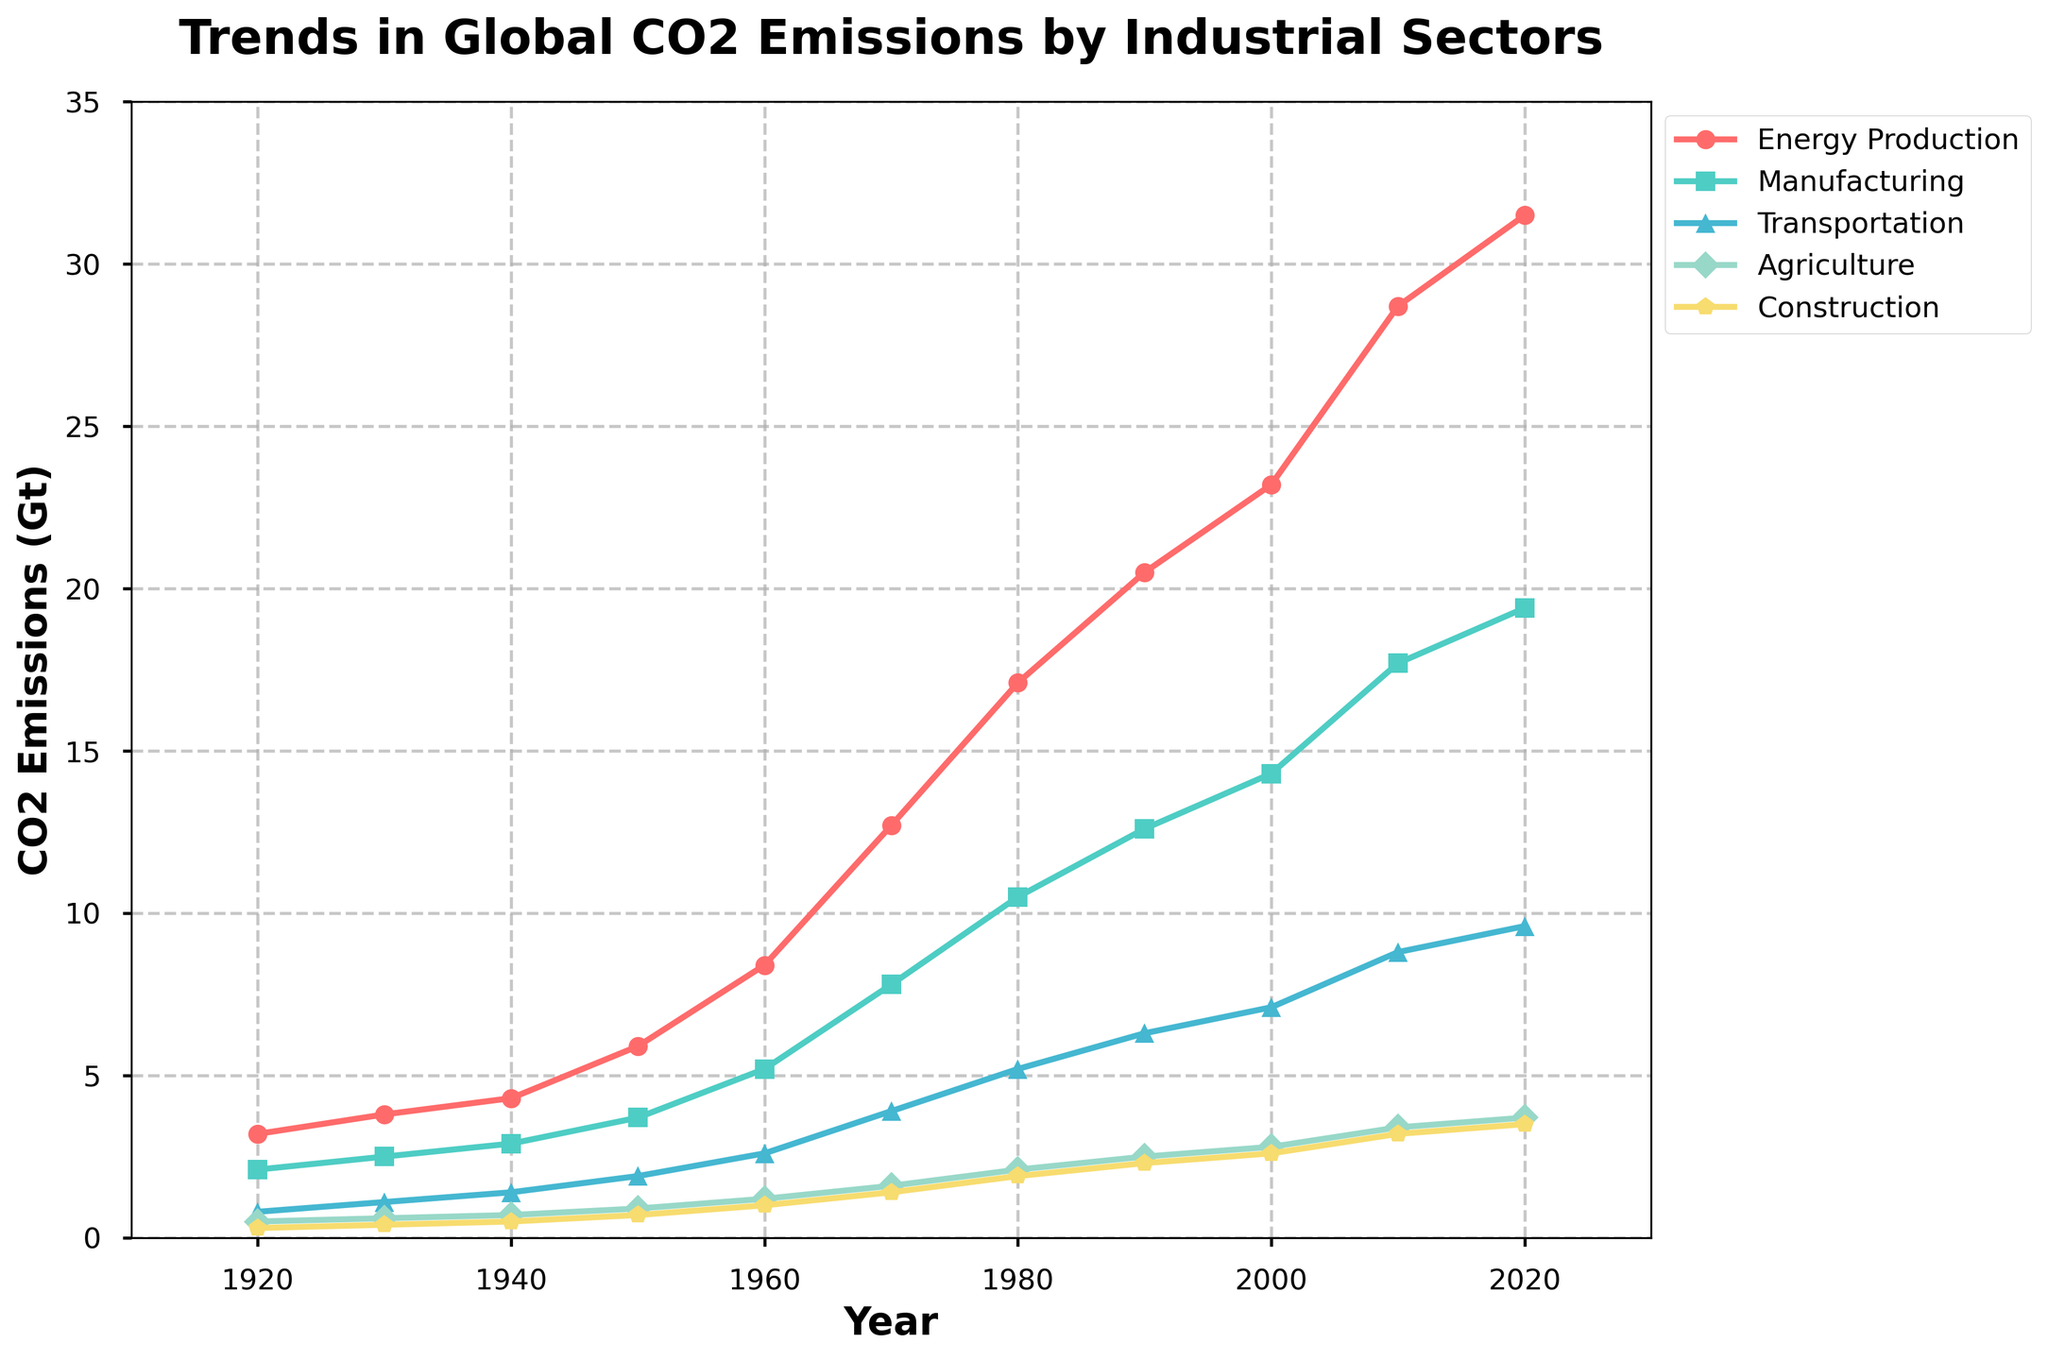What was the CO2 emission from the Energy Production sector in 1920? Look at the 'Energy Production' line in the chart and locate the data point for the year 1920.
Answer: 3.2 Gt Which sector had the highest CO2 emissions in 2010? Locate the year 2010 on the x-axis. Among all the lines for different sectors, observe which line is highest vertically.
Answer: Energy Production How did the CO2 emissions from Manufacturing change from 1980 to 2000? Locate the 'Manufacturing' line and compare the emission values at the year 1980 and the year 2000. Take the difference between the two values.
Answer: Increased by 3.8 Gt (14.3 - 10.5) By how much did the CO2 emissions from Transportation increase from 1960 to 2020? Locate the 'Transportation' line and compare the values at 1960 and 2020. Calculate the difference between the two values.
Answer: Increased by 7.0 Gt (9.6 - 2.6) Which sector showed the smallest increase in CO2 emissions between 1920 and 2020? Calculate the difference in CO2 emissions for each sector between the years 1920 and 2020. Compare the differences to determine the smallest increase.
Answer: Construction (3.5 - 0.3 = 3.2 Gt) What was the approximate total CO2 emissions from all sectors in 1970? Add up the CO2 emissions for each sector in the year 1970.
Answer: 27.4 Gt (12.7 + 7.8 + 3.9 + 1.6 + 1.4) Which sector experienced the most rapid growth in CO2 emissions between 1950 and 1970? Calculate the rate of change for each sector's CO2 emissions between 1950 and 1970. The sector with the largest difference is the one with the most rapid growth.
Answer: Energy Production (12.7 - 5.9 = 6.8 Gt) Are there any years where all sectors showed a rise in CO2 emissions compared to the previous decade? For each decade, compare the CO2 emission values to the values of the previous decade for all sectors. Identify if there are any such periods.
Answer: Yes, between 1950 and 1960 Which sector had the highest percentage increase in CO2 emissions from 1920 to 1960? Calculate the percentage increase for each sector from 1920 to 1960 using the formula: ((Value in 1960 - Value in 1920) / Value in 1920) * 100. Compare the percentages.
Answer: Transportation (((2.6 - 0.8) / 0.8) * 100 = 225%) 